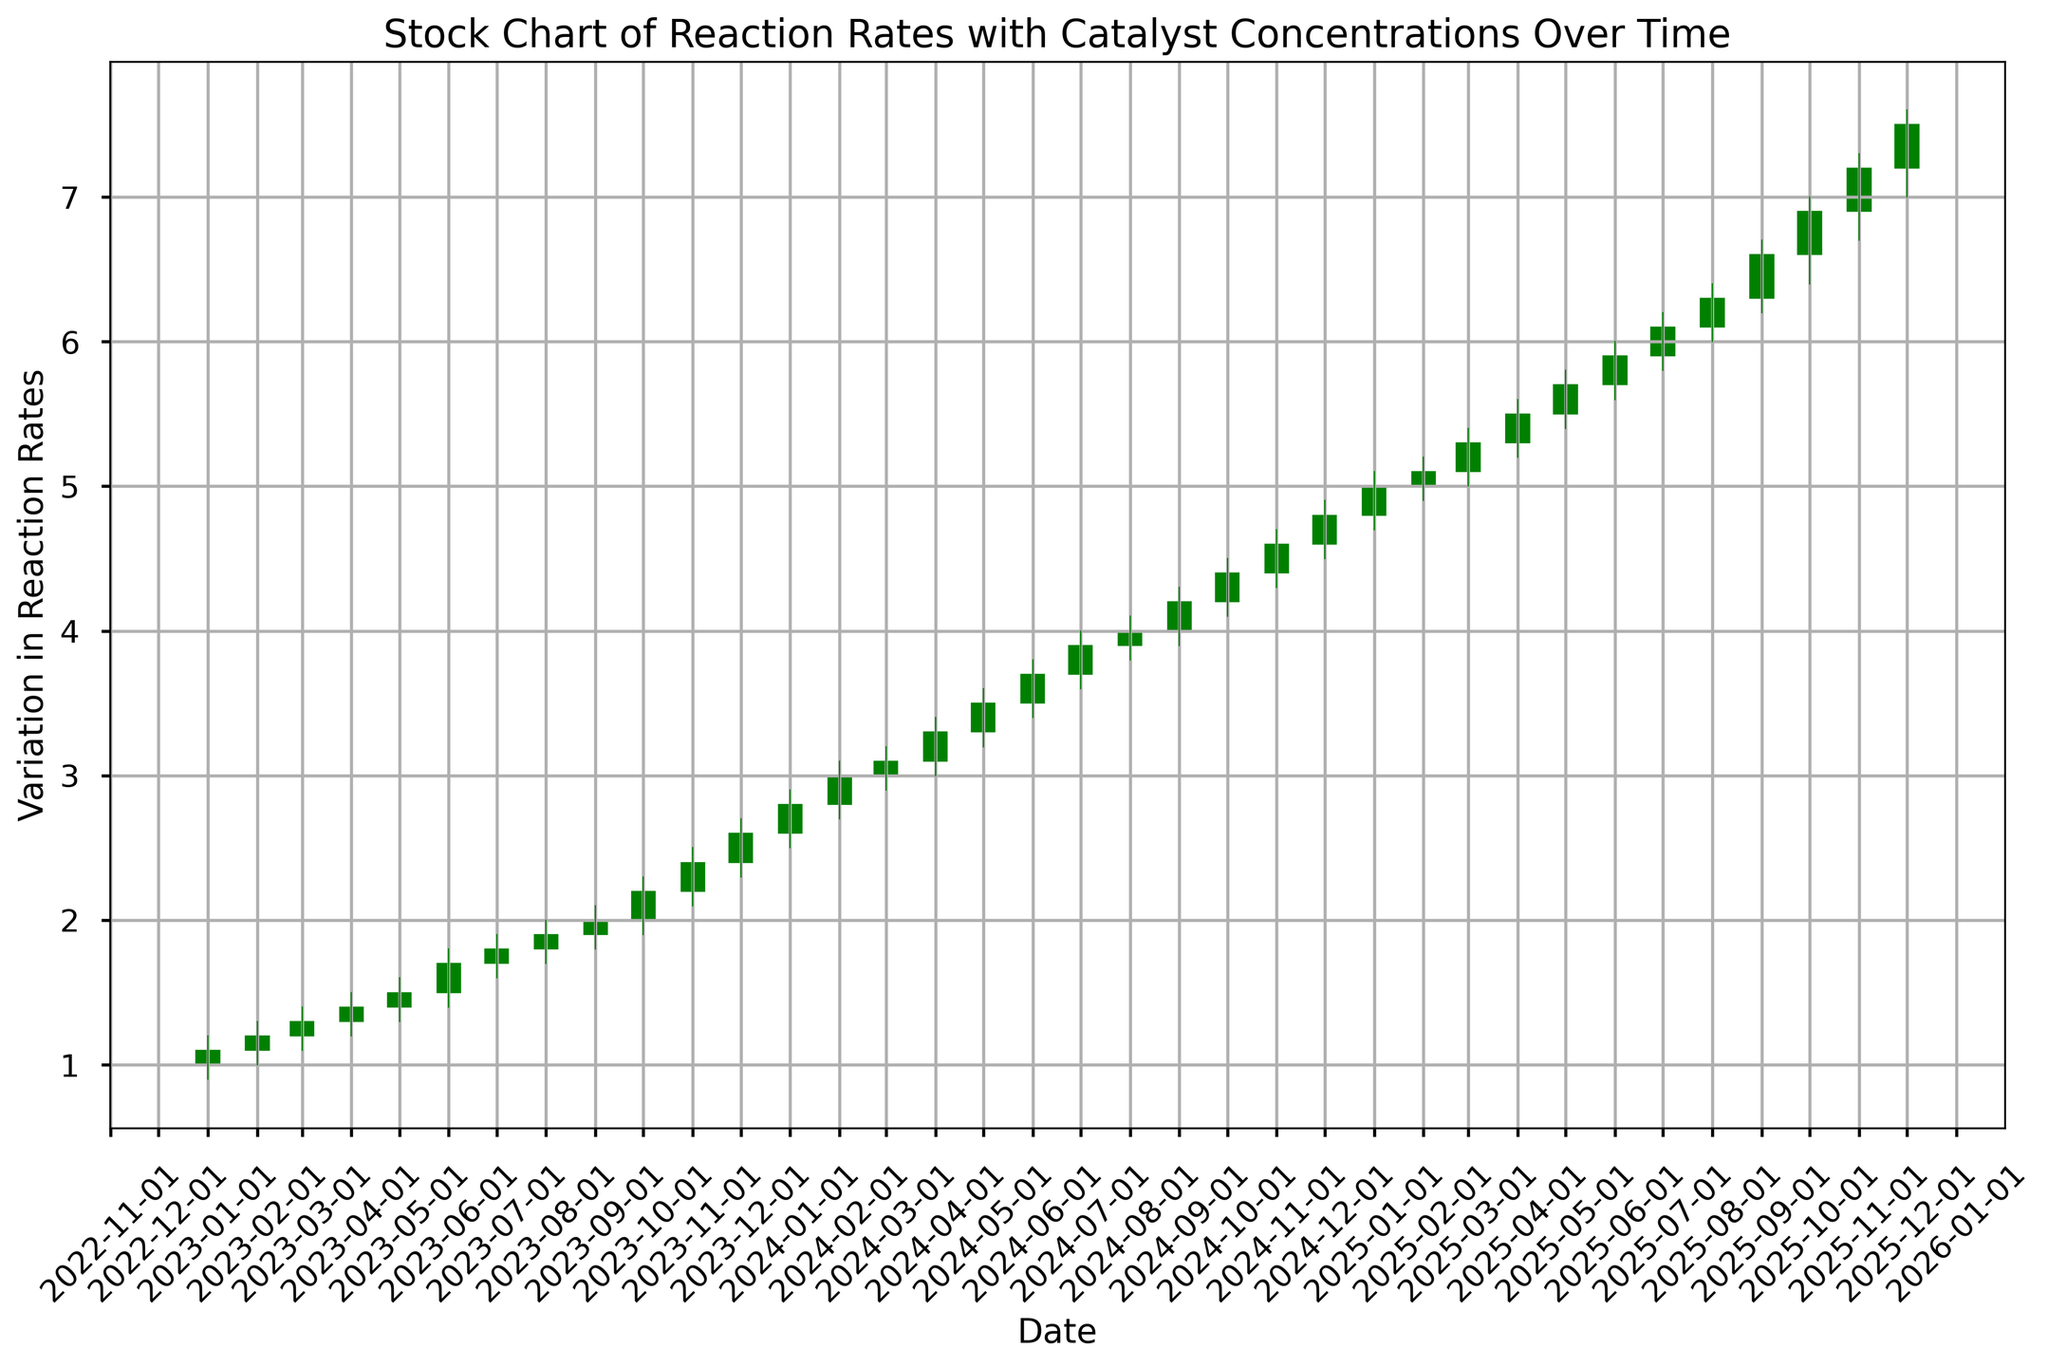What is the general trend of the reaction rates over time? The general trend is observed by looking at the overall movement of the candlesticks from the left (start) to the right (end) of the figure. The figure shows an increasing trend, indicating that reaction rates increase over time as catalyst concentrations increase.
Answer: Increasing In which month did the reaction rate have the highest high value? We can identify the highest point of the candlesticks in the figure. The highest high value appears in December 2025.
Answer: December 2025 How many months showed a decreasing trend in the reaction rate? A decreasing trend in the reaction rate is indicated by red candlesticks. By counting the red candlesticks, we notice there are a few time periods where the open value is higher than the close value, indicating a decrease in reaction rates for those months.
Answer: Few Which month had the highest closing value? By observing the top of the green sections of the candlesticks (representing closing values) over the entire time period, we can identify that the highest closing value is in December 2025.
Answer: December 2025 Compare the reaction rates between January 2023 and January 2024. Which month had a higher closing value? By examining the closing values of the candlestick for January 2023 and January 2024, we see that January 2024 has a higher closing value compared to January 2023.
Answer: January 2024 Find the month where there was the sharpest increase in reaction rates. The sharpest increase in reaction rates can be identified by a significant jump from the open to the close within one month. By comparing all the candlesticks, the sharpest increase is seen in January 2024.
Answer: January 2024 During which month did the reaction rate experience the largest range (difference between high and low)? The largest range can be determined by observing the length of the candlesticks. The month with the largest range is January 2024, when comparing the difference between the high and low values.
Answer: January 2024 What was the closing value in June 2024? The closing value for June 2024 can be read directly from the top of the green portion of the candlestick for that month. The closing value was 3.7 in June 2024.
Answer: 3.7 